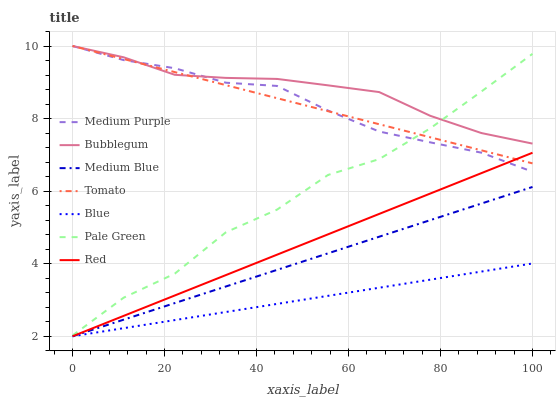Does Medium Blue have the minimum area under the curve?
Answer yes or no. No. Does Medium Blue have the maximum area under the curve?
Answer yes or no. No. Is Medium Blue the smoothest?
Answer yes or no. No. Is Medium Blue the roughest?
Answer yes or no. No. Does Bubblegum have the lowest value?
Answer yes or no. No. Does Medium Blue have the highest value?
Answer yes or no. No. Is Red less than Bubblegum?
Answer yes or no. Yes. Is Bubblegum greater than Red?
Answer yes or no. Yes. Does Red intersect Bubblegum?
Answer yes or no. No. 